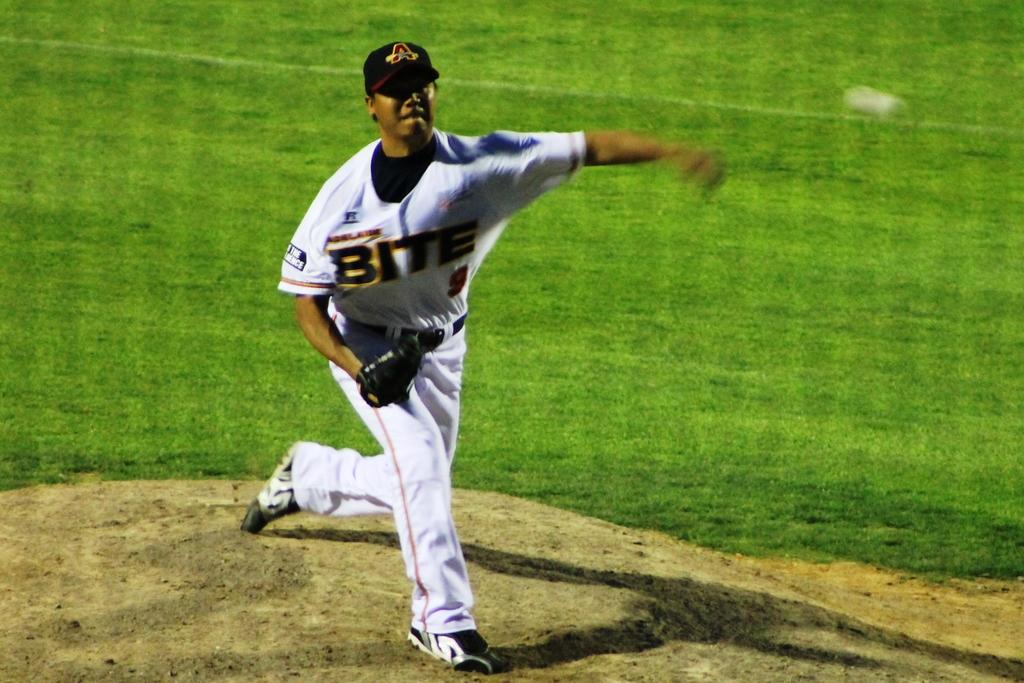What letter is on his hat?
Your answer should be very brief. A. 